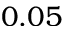Convert formula to latex. <formula><loc_0><loc_0><loc_500><loc_500>0 . 0 5</formula> 